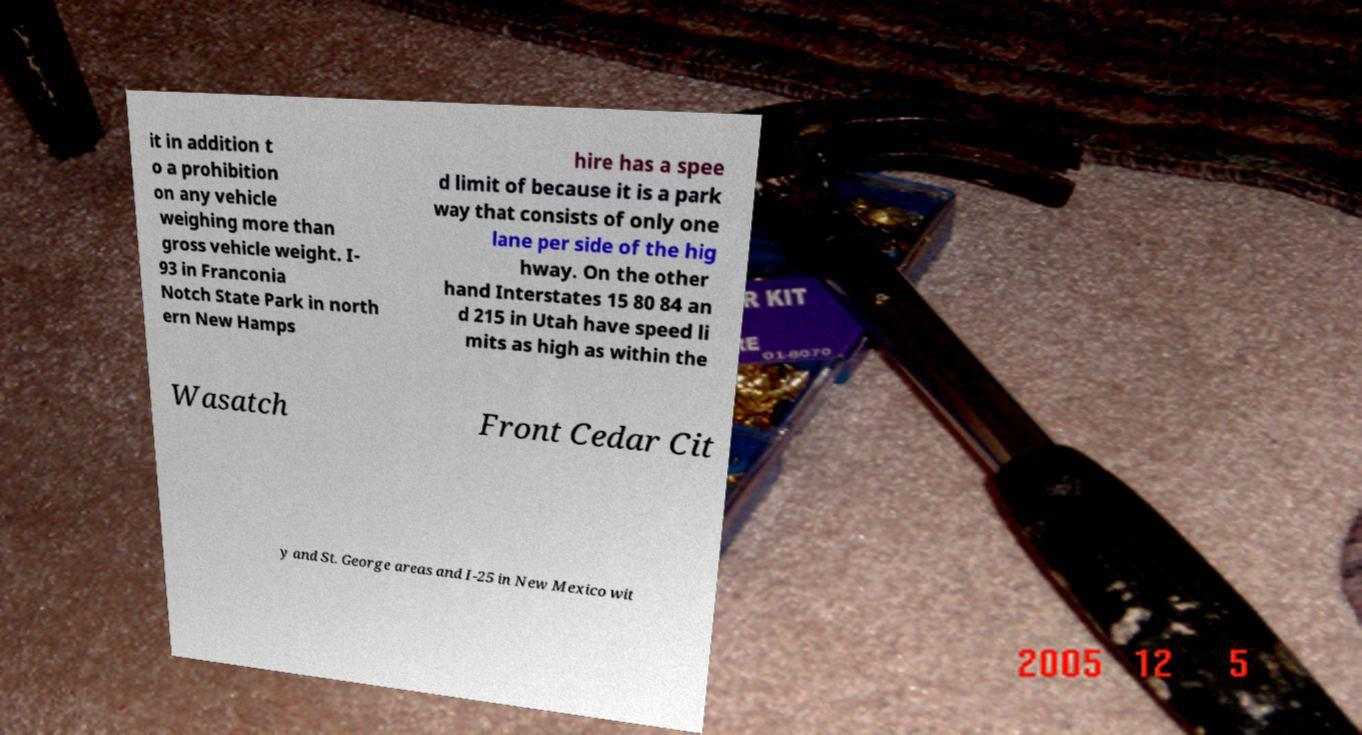There's text embedded in this image that I need extracted. Can you transcribe it verbatim? it in addition t o a prohibition on any vehicle weighing more than gross vehicle weight. I- 93 in Franconia Notch State Park in north ern New Hamps hire has a spee d limit of because it is a park way that consists of only one lane per side of the hig hway. On the other hand Interstates 15 80 84 an d 215 in Utah have speed li mits as high as within the Wasatch Front Cedar Cit y and St. George areas and I-25 in New Mexico wit 